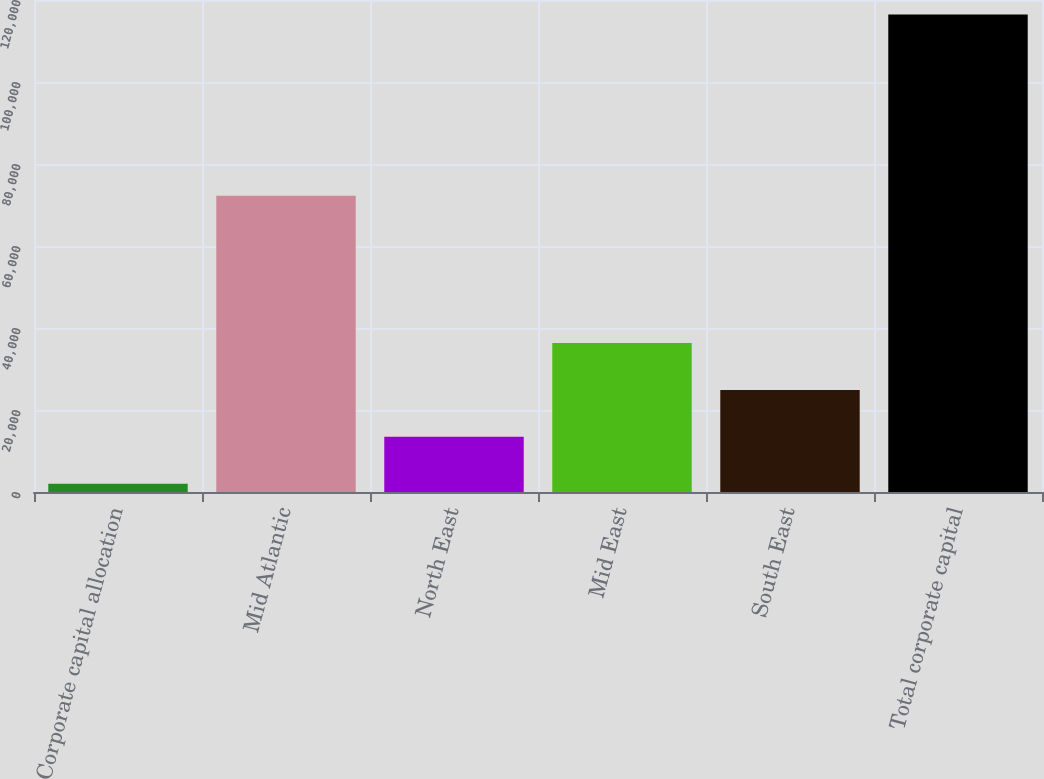Convert chart. <chart><loc_0><loc_0><loc_500><loc_500><bar_chart><fcel>Corporate capital allocation<fcel>Mid Atlantic<fcel>North East<fcel>Mid East<fcel>South East<fcel>Total corporate capital<nl><fcel>2013<fcel>72272<fcel>13457.5<fcel>36346.5<fcel>24902<fcel>116458<nl></chart> 